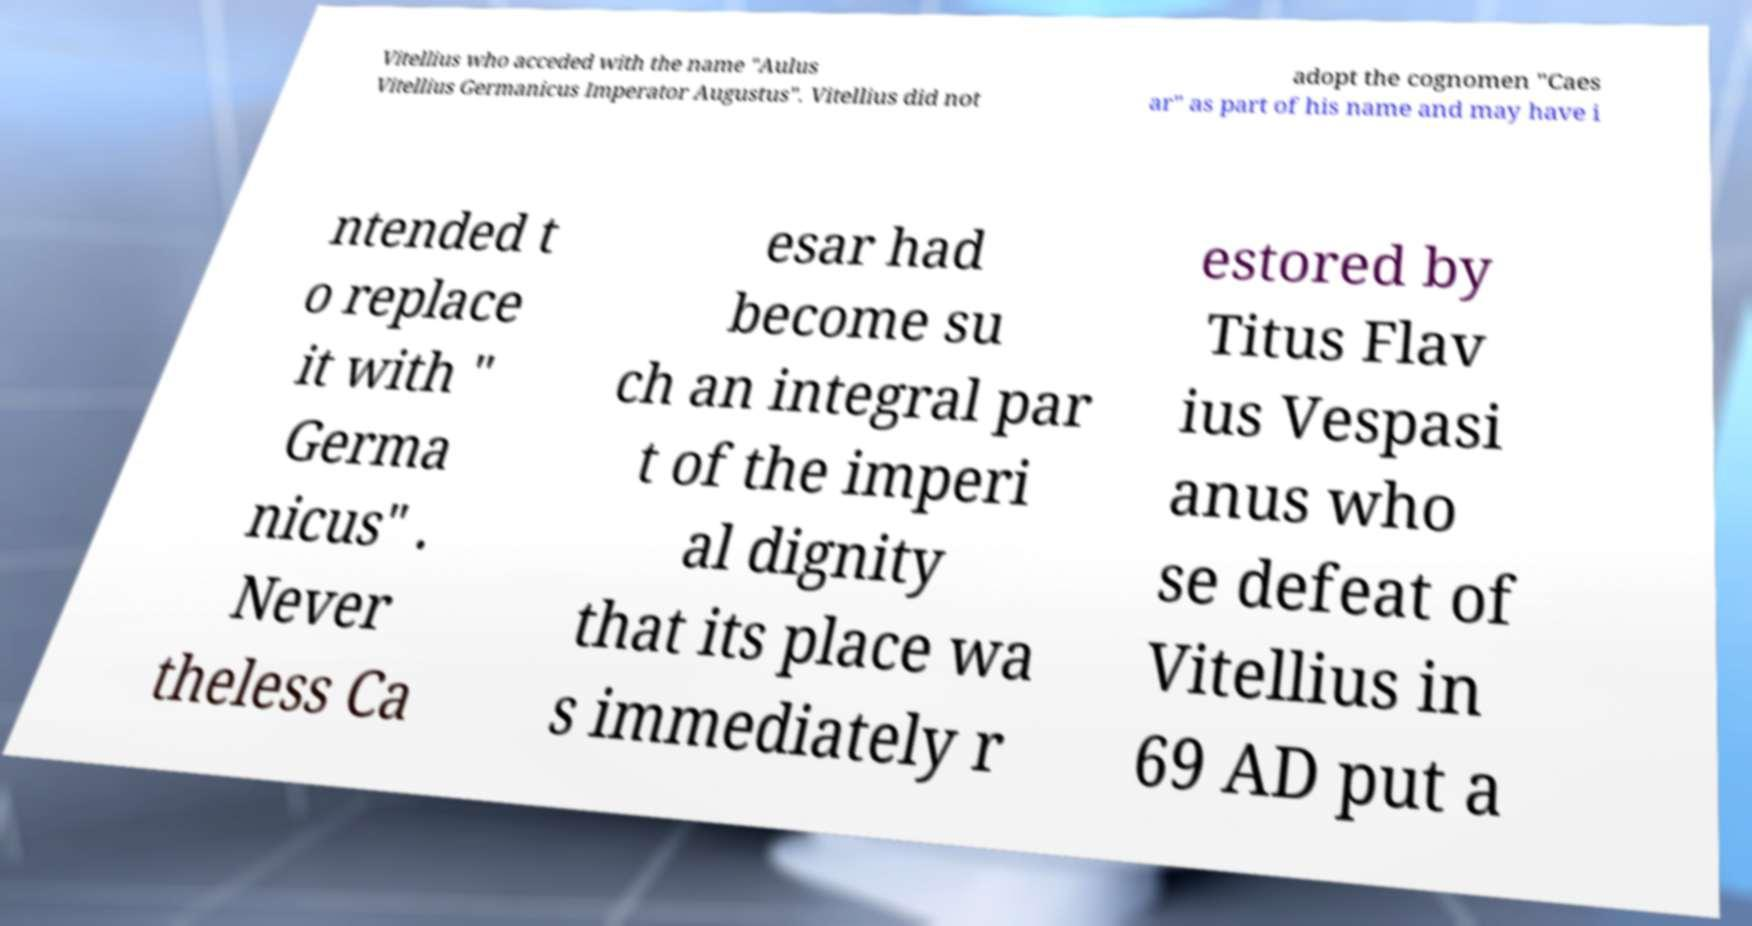There's text embedded in this image that I need extracted. Can you transcribe it verbatim? Vitellius who acceded with the name "Aulus Vitellius Germanicus Imperator Augustus". Vitellius did not adopt the cognomen "Caes ar" as part of his name and may have i ntended t o replace it with " Germa nicus" . Never theless Ca esar had become su ch an integral par t of the imperi al dignity that its place wa s immediately r estored by Titus Flav ius Vespasi anus who se defeat of Vitellius in 69 AD put a 